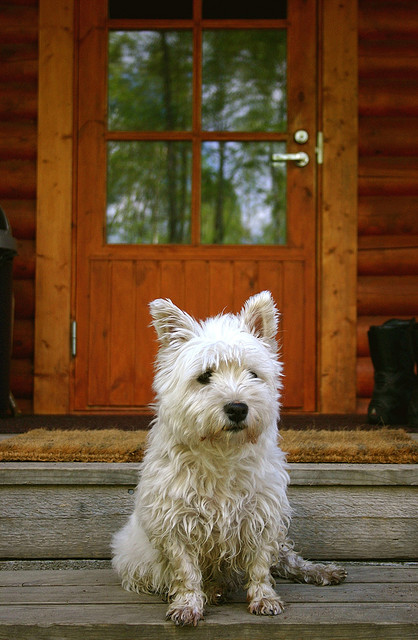<image>What breed of dog is this? I don't know the breed of the dog. It can be a terrier, shih tzu, poodle, westie, or maltese. What breed of dog is this? I don't know the breed of the dog in the image. It can be terrier, shih tzu, poodle, westie, maltese, or another breed. 